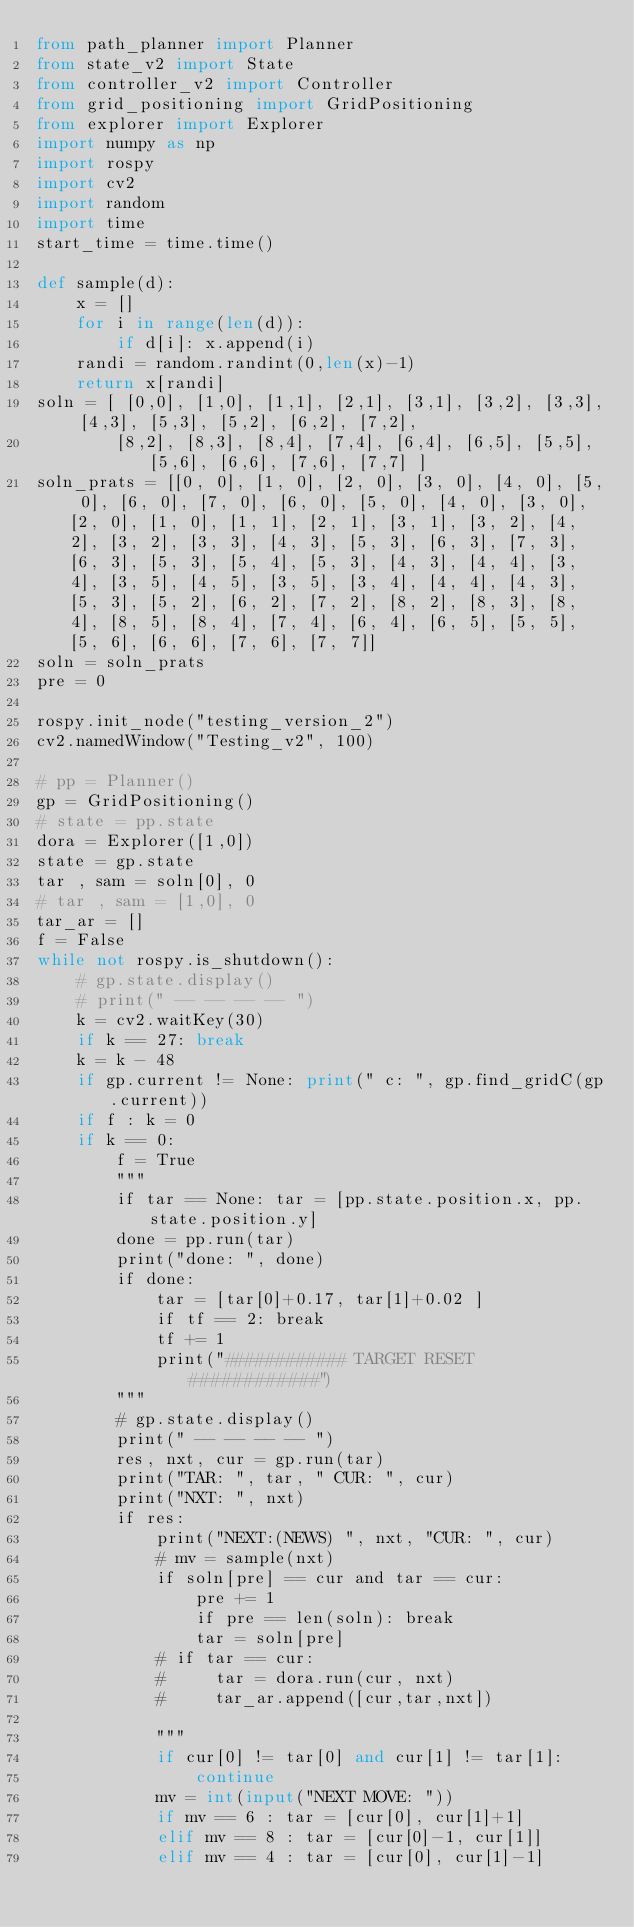<code> <loc_0><loc_0><loc_500><loc_500><_Python_>from path_planner import Planner
from state_v2 import State
from controller_v2 import Controller
from grid_positioning import GridPositioning
from explorer import Explorer
import numpy as np
import rospy
import cv2
import random
import time
start_time = time.time()

def sample(d):
    x = []
    for i in range(len(d)):
        if d[i]: x.append(i)
    randi = random.randint(0,len(x)-1)
    return x[randi]
soln = [ [0,0], [1,0], [1,1], [2,1], [3,1], [3,2], [3,3], [4,3], [5,3], [5,2], [6,2], [7,2],
        [8,2], [8,3], [8,4], [7,4], [6,4], [6,5], [5,5], [5,6], [6,6], [7,6], [7,7] ]
soln_prats = [[0, 0], [1, 0], [2, 0], [3, 0], [4, 0], [5, 0], [6, 0], [7, 0], [6, 0], [5, 0], [4, 0], [3, 0], [2, 0], [1, 0], [1, 1], [2, 1], [3, 1], [3, 2], [4, 2], [3, 2], [3, 3], [4, 3], [5, 3], [6, 3], [7, 3], [6, 3], [5, 3], [5, 4], [5, 3], [4, 3], [4, 4], [3, 4], [3, 5], [4, 5], [3, 5], [3, 4], [4, 4], [4, 3], [5, 3], [5, 2], [6, 2], [7, 2], [8, 2], [8, 3], [8, 4], [8, 5], [8, 4], [7, 4], [6, 4], [6, 5], [5, 5], [5, 6], [6, 6], [7, 6], [7, 7]]
soln = soln_prats
pre = 0

rospy.init_node("testing_version_2")
cv2.namedWindow("Testing_v2", 100)

# pp = Planner()
gp = GridPositioning()
# state = pp.state
dora = Explorer([1,0])
state = gp.state
tar , sam = soln[0], 0
# tar , sam = [1,0], 0
tar_ar = []
f = False
while not rospy.is_shutdown():
    # gp.state.display()
    # print(" -- -- -- -- ")
    k = cv2.waitKey(30)
    if k == 27: break
    k = k - 48
    if gp.current != None: print(" c: ", gp.find_gridC(gp.current))
    if f : k = 0
    if k == 0:
        f = True
        """
        if tar == None: tar = [pp.state.position.x, pp.state.position.y]
        done = pp.run(tar)
        print("done: ", done)
        if done: 
            tar = [tar[0]+0.17, tar[1]+0.02 ]
            if tf == 2: break
            tf += 1
            print("############ TARGET RESET ############")
        """
        # gp.state.display()
        print(" -- -- -- -- ")
        res, nxt, cur = gp.run(tar)
        print("TAR: ", tar, " CUR: ", cur)
        print("NXT: ", nxt)
        if res:
            print("NEXT:(NEWS) ", nxt, "CUR: ", cur)
            # mv = sample(nxt)
            if soln[pre] == cur and tar == cur:
                pre += 1
                if pre == len(soln): break
                tar = soln[pre]
            # if tar == cur:
            #     tar = dora.run(cur, nxt)
            #     tar_ar.append([cur,tar,nxt])

            """
            if cur[0] != tar[0] and cur[1] != tar[1]:
                continue 
            mv = int(input("NEXT MOVE: "))
            if mv == 6 : tar = [cur[0], cur[1]+1]
            elif mv == 8 : tar = [cur[0]-1, cur[1]]
            elif mv == 4 : tar = [cur[0], cur[1]-1]</code> 